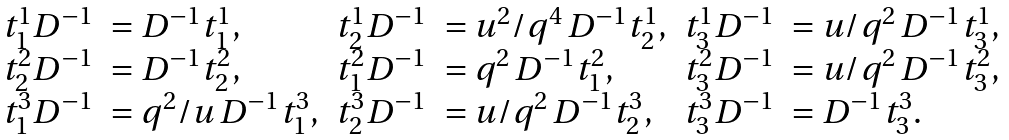Convert formula to latex. <formula><loc_0><loc_0><loc_500><loc_500>\begin{array} { l l l l l l } t ^ { 1 } _ { 1 } D ^ { - 1 } & = D ^ { - 1 } t ^ { 1 } _ { 1 } , & t ^ { 1 } _ { 2 } D ^ { - 1 } & = u ^ { 2 } / q ^ { 4 } \, D ^ { - 1 } t ^ { 1 } _ { 2 } , & t ^ { 1 } _ { 3 } D ^ { - 1 } & = u / q ^ { 2 } \, D ^ { - 1 } t ^ { 1 } _ { 3 } , \\ t ^ { 2 } _ { 2 } D ^ { - 1 } & = D ^ { - 1 } t ^ { 2 } _ { 2 } , & t ^ { 2 } _ { 1 } D ^ { - 1 } & = q ^ { 2 } \, D ^ { - 1 } t ^ { 2 } _ { 1 } , & t ^ { 2 } _ { 3 } D ^ { - 1 } & = u / q ^ { 2 } \, D ^ { - 1 } t ^ { 2 } _ { 3 } , \\ t ^ { 3 } _ { 1 } D ^ { - 1 } & = q ^ { 2 } / u \, D ^ { - 1 } t ^ { 3 } _ { 1 } , & t ^ { 3 } _ { 2 } D ^ { - 1 } & = u / q ^ { 2 } \, D ^ { - 1 } t ^ { 3 } _ { 2 } , & t ^ { 3 } _ { 3 } D ^ { - 1 } & = D ^ { - 1 } t ^ { 3 } _ { 3 } . \\ \end{array}</formula> 